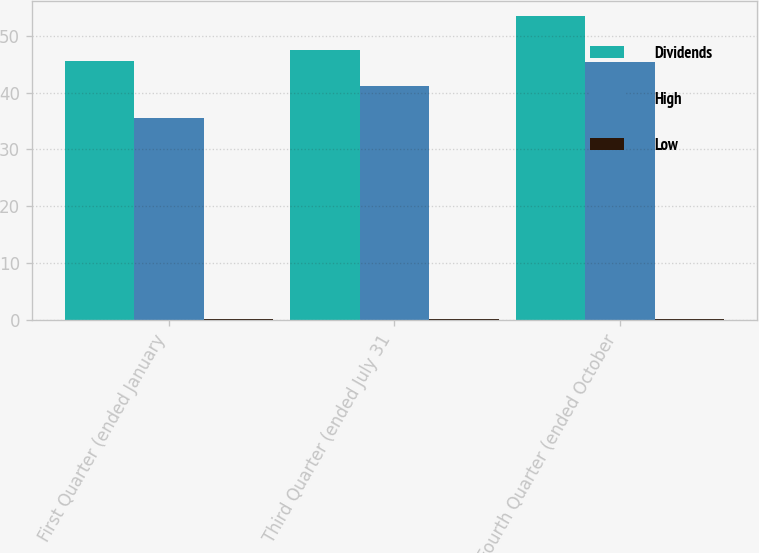Convert chart. <chart><loc_0><loc_0><loc_500><loc_500><stacked_bar_chart><ecel><fcel>First Quarter (ended January<fcel>Third Quarter (ended July 31<fcel>Fourth Quarter (ended October<nl><fcel>Dividends<fcel>45.55<fcel>47.47<fcel>53.47<nl><fcel>High<fcel>35.45<fcel>41.24<fcel>45.32<nl><fcel>Low<fcel>0.22<fcel>0.12<fcel>0.12<nl></chart> 